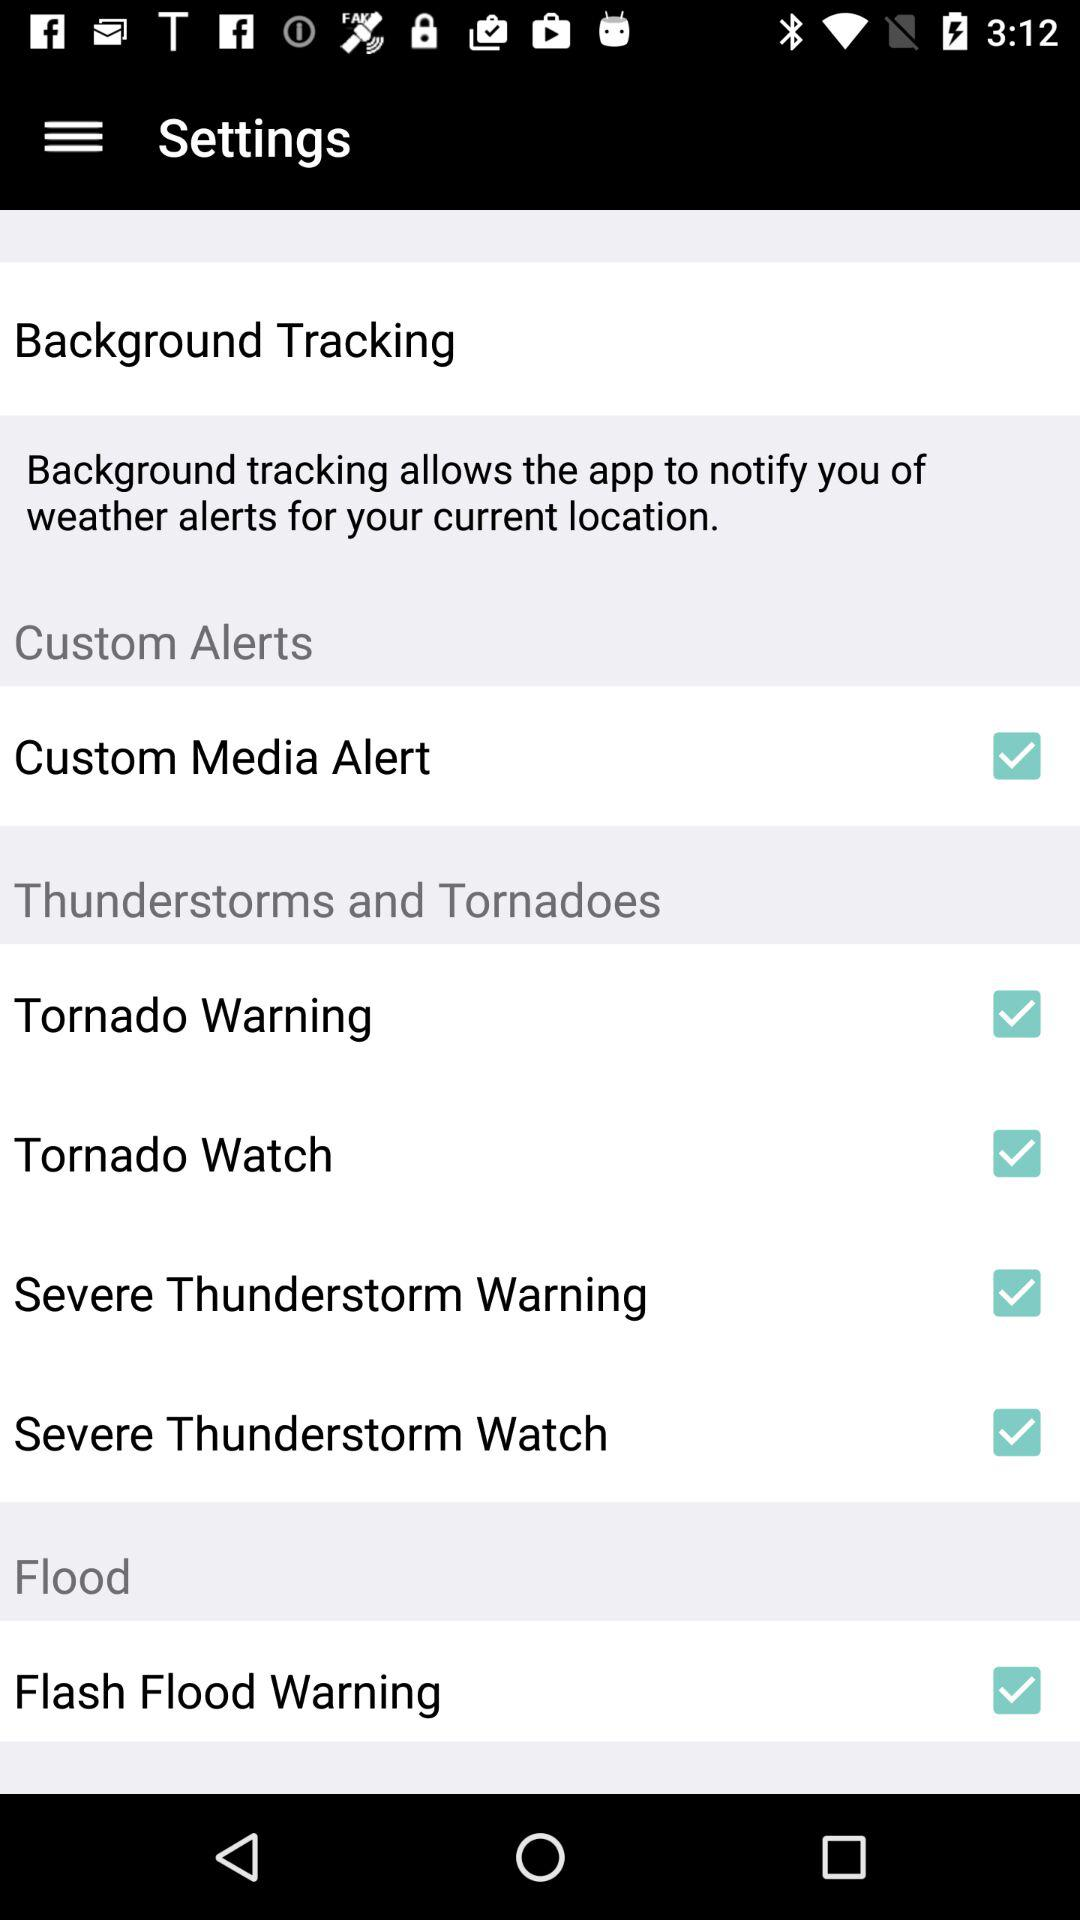What is the status of "Custom Media Alert"? The status is "on". 